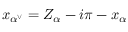Convert formula to latex. <formula><loc_0><loc_0><loc_500><loc_500>x _ { \alpha ^ { \vee } } = Z _ { \alpha } - i \pi - x _ { \alpha }</formula> 